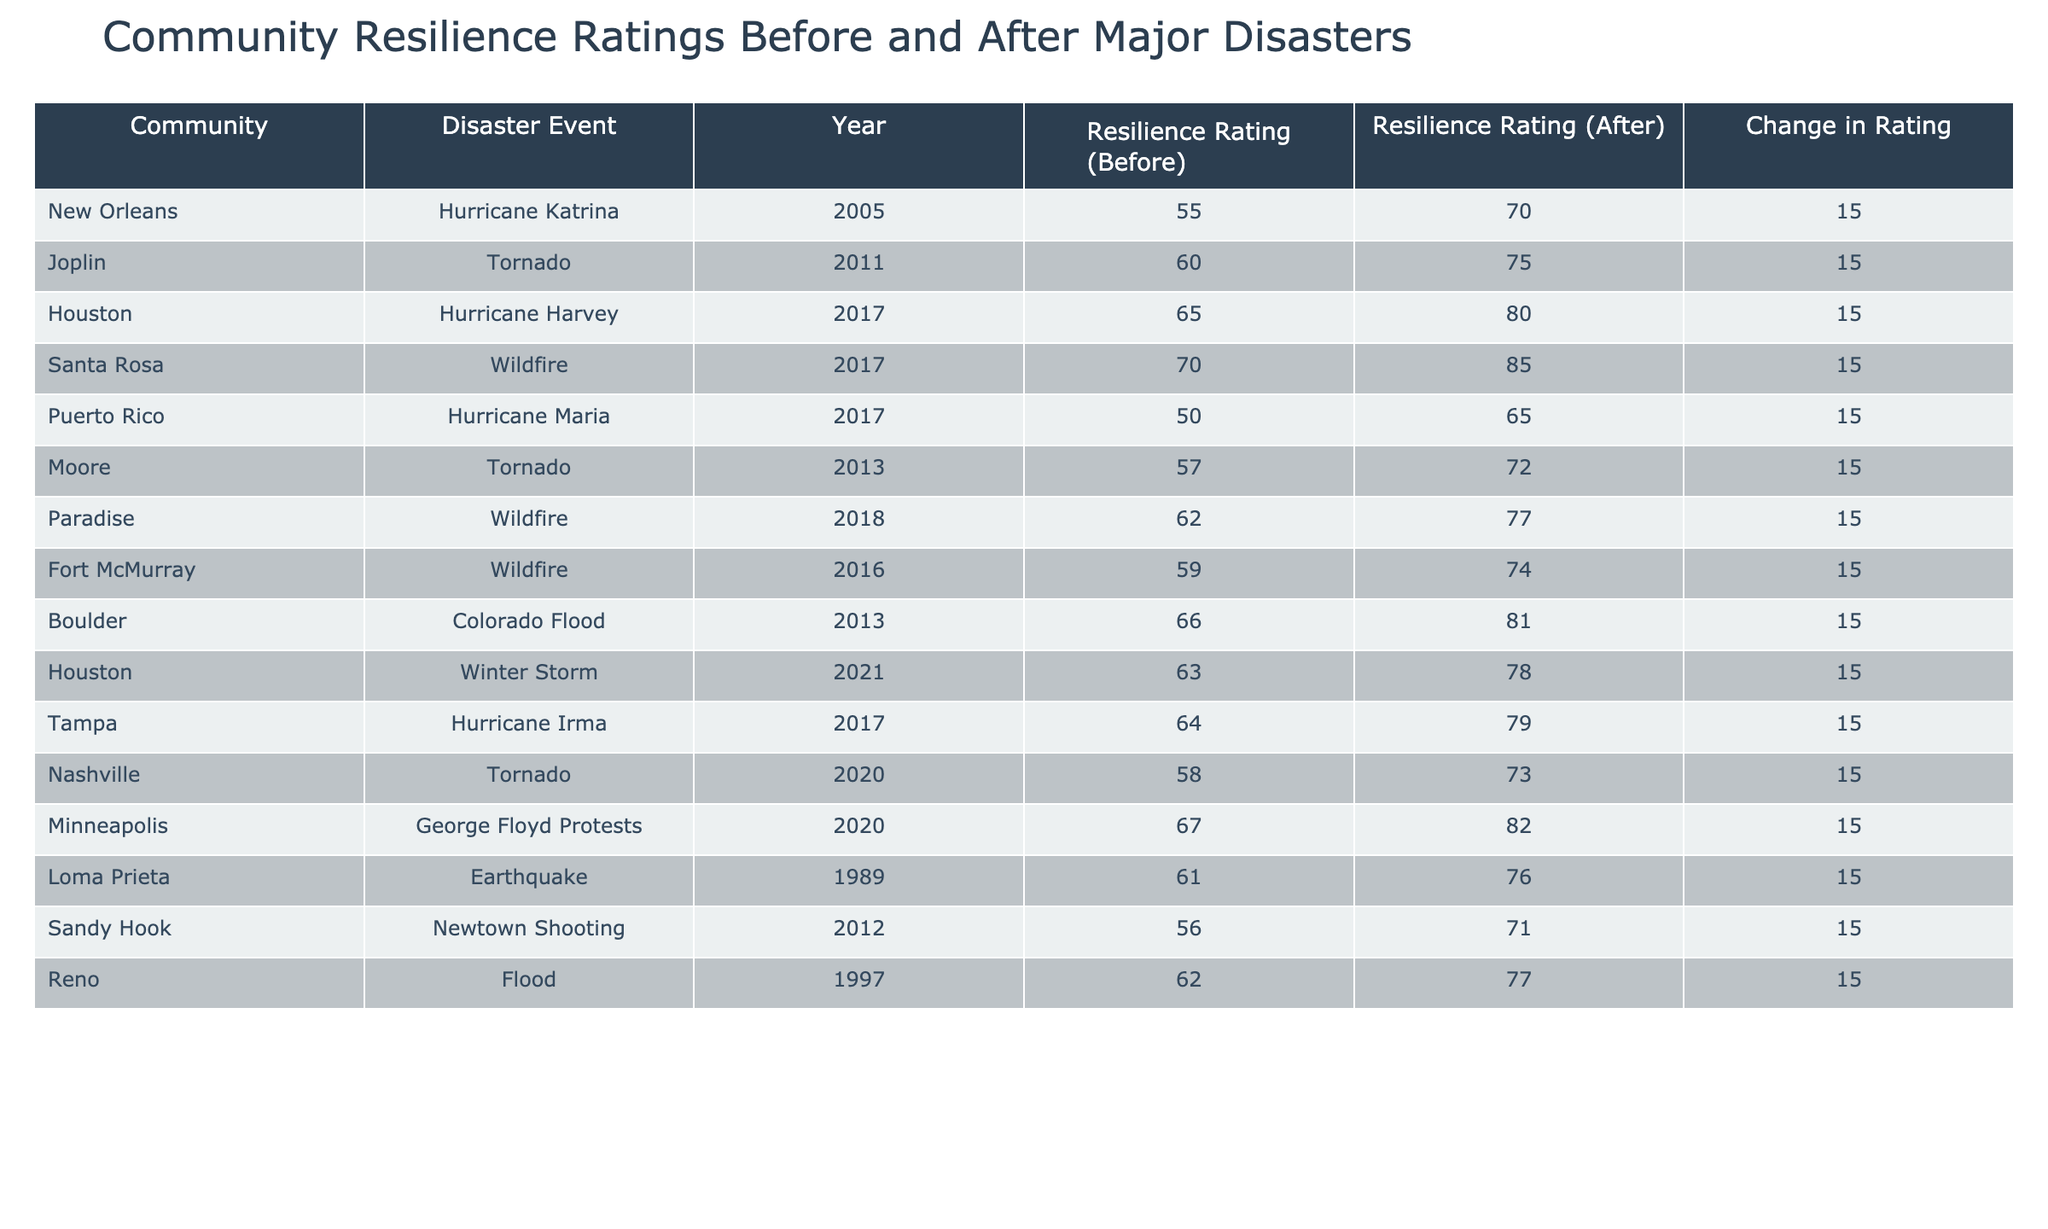What was the resilience rating for Puerto Rico before Hurricane Maria? The table shows that the resilience rating for Puerto Rico before Hurricane Maria in 2017 was 50.
Answer: 50 What was the change in resilience rating for Joplin after the tornado in 2011? The change in resilience rating for Joplin after the tornado in 2011 was 15, as the rating changed from 60 to 75.
Answer: 15 Which community had the highest resilience rating after their disaster event? Santa Rosa had the highest resilience rating after the wildfire in 2017, with a rating of 85.
Answer: 85 How many communities had a resilience rating of 70 or higher after their respective disasters? After reviewing the table, 6 communities had a resilience rating of 70 or higher after their disasters: New Orleans, Joplin, Houston, Santa Rosa, Houston (Winter Storm), and Minneapolis.
Answer: 6 Was the resilience rating for Paradise before its disaster higher than that of Moore before their tornado? The resilience rating for Paradise before the disaster was 62, while Moore's was 57, which means Paradise's rating was higher.
Answer: Yes What is the average resilience rating before the disasters listed in the table? To find the average, sum the resilience ratings before the disasters: 55 + 60 + 65 + 70 + 50 + 57 + 62 + 59 + 66 + 63 + 64 + 58 + 67 + 61 + 56 + 62 = 1,006. There are 15 communities, so the average is 1,006 / 15 ≈ 67.07.
Answer: 67.07 Which disaster event had a resilience rating change equal to the average change for all the events? The average change for all events is consistently 15, so all disaster events listed experienced a change of 15.
Answer: All events What is the total resilience rating for all communities after their respective disasters? To calculate the total resilience rating after disasters, sum the ratings: 70 + 75 + 80 + 85 + 65 + 72 + 77 + 74 + 81 + 78 + 79 + 73 + 82 + 76 + 71 + 77 = 1,186.
Answer: 1,186 Which community showed the least improvement in resilience rating after the disaster? Every community listed showed the same improvement of 15, so there is no community that showed less improvement relative to others.
Answer: None Was the resilience rating after the disaster in New Orleans greater than 75? After the disaster, New Orleans had a resilience rating of 70, which is not greater than 75.
Answer: No 